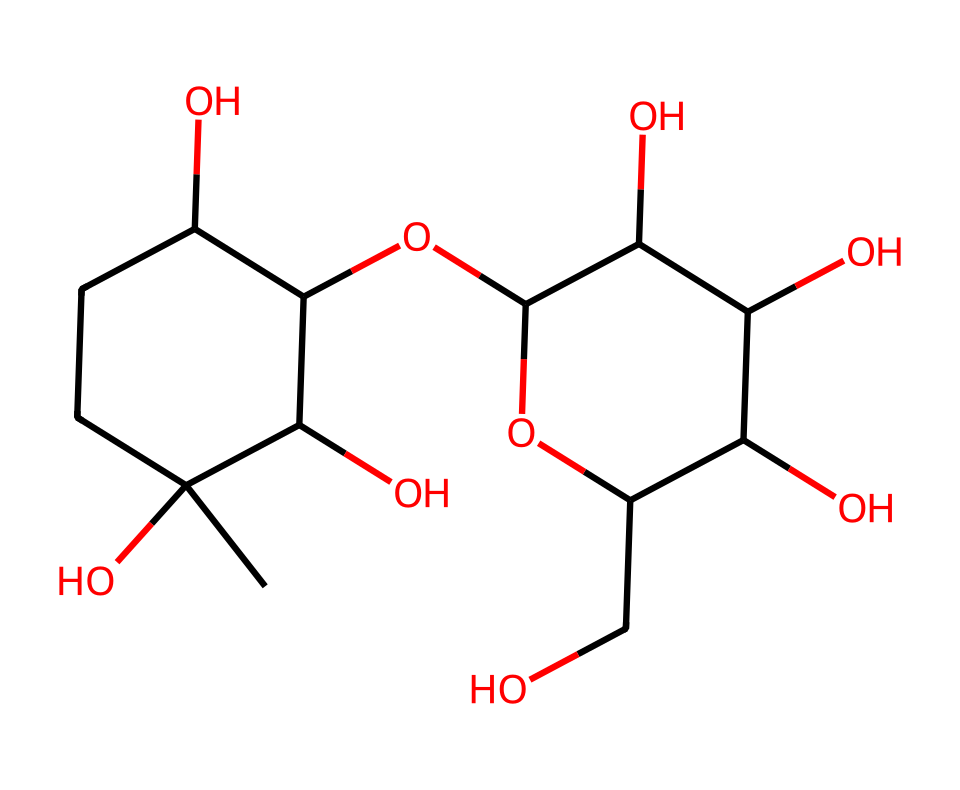What is the primary carbohydrate structure represented here? The chemical structure represents beta-glucans, which are polysaccharides composed of glucose units linked by beta-glycosidic bonds.
Answer: beta-glucans How many rings are present in this structure? By analyzing the SMILES representation, there are two distinct cyclic structures indicated, which can be inferred from the presence of "C" groups with ring closure numbers.
Answer: 2 What is the total number of oxygen atoms in this molecule? Counting the oxygen atoms indicated in the structure, we find four distinct oxygen atoms present, which can be seen in hydroxyl groups and the ether linkages.
Answer: 4 Does this molecule have branching points? The structure shows branches due to the presence of hydroxyl regions and the linked glucose units, indicating that this carbohydrate is not linear but branched.
Answer: Yes What feature of this carbohydrate contributes to the mouthfeel in beer? The presence of beta-glucans influences viscosity, leading to a richer mouthfeel as they contribute to the thickness and texture of the beer, enhancing its sensory characteristics.
Answer: Viscosity 